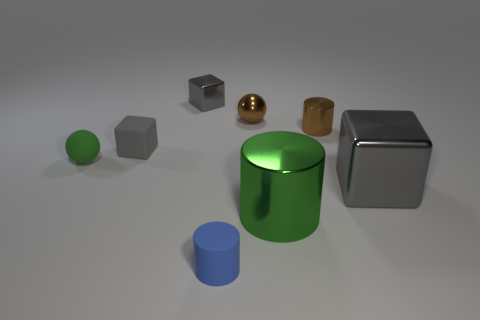Can you describe the shapes and their colors in the image? Certainly! The image includes a variety of geometric shapes with different colors. From left to right: there's a small green sphere, a medium gray cube, a small golden sphere, a brown cube that appears to be slightly transparent, a large shiny green cylinder, and a large reflective silver cube. There's also a small blue cylinder in front. 